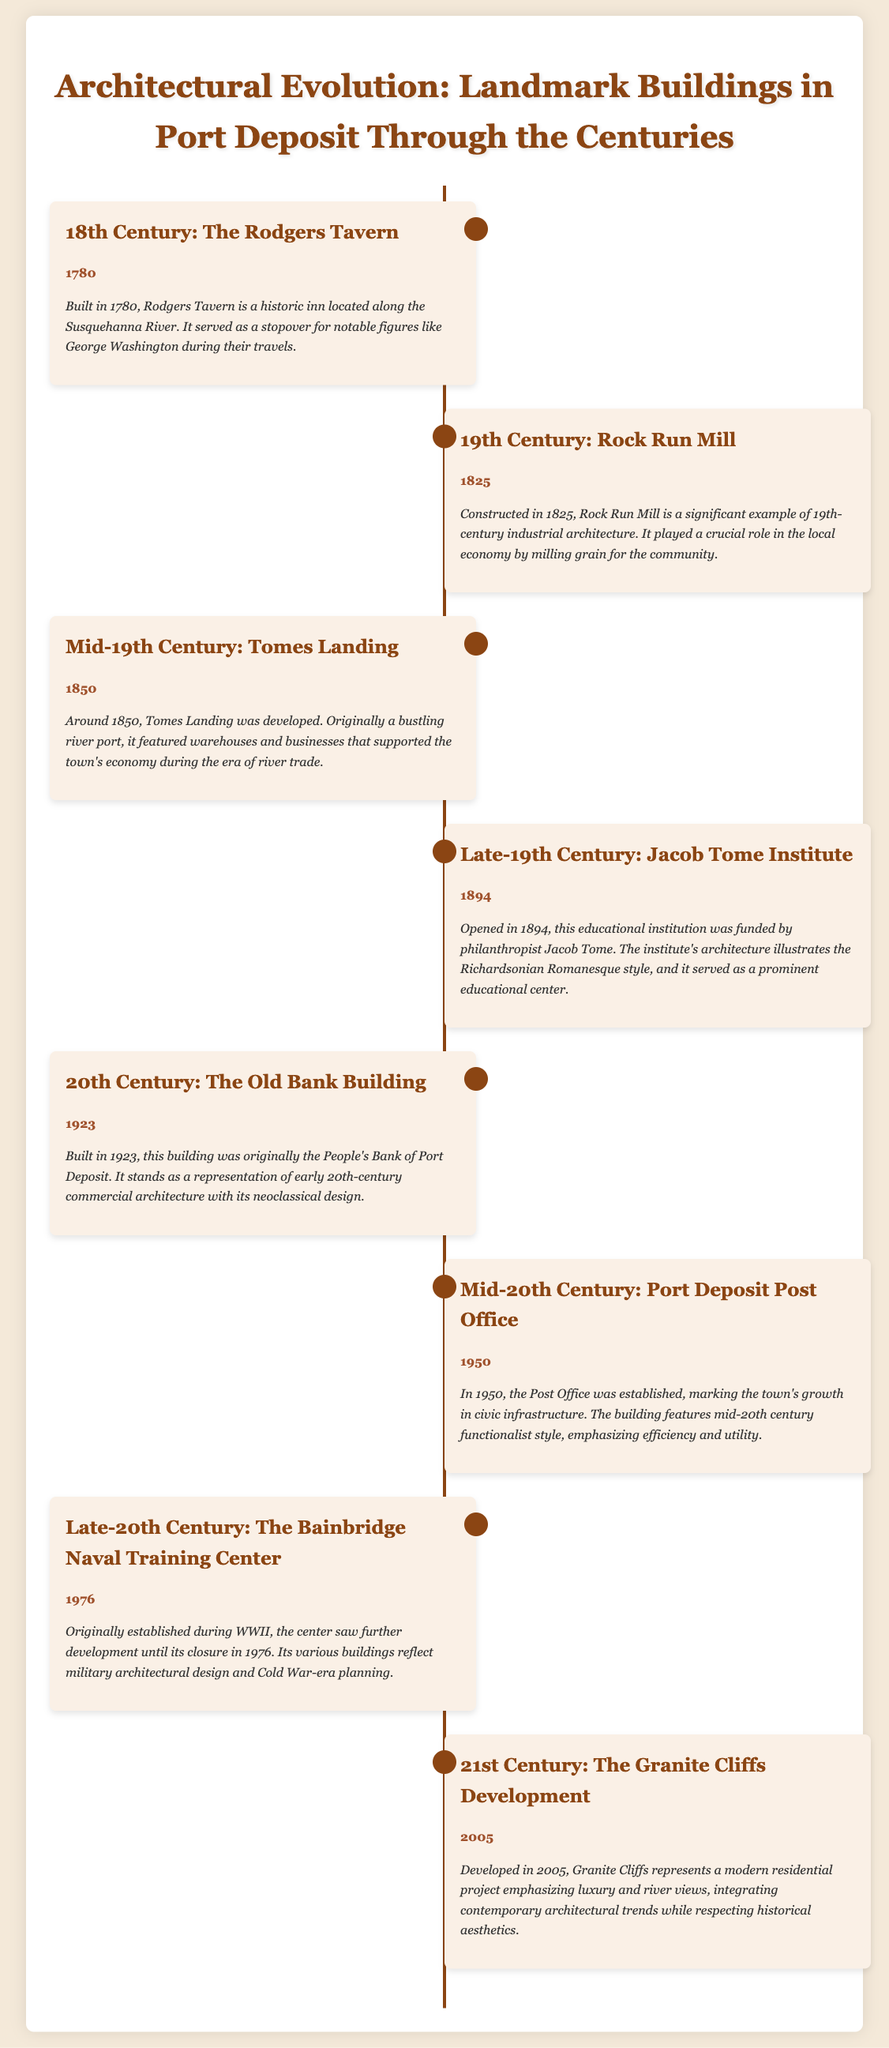What year was Rodgers Tavern built? The document states that Rodgers Tavern was built in the year 1780.
Answer: 1780 What architectural style is the Jacob Tome Institute associated with? The document describes the Jacob Tome Institute's architecture as illustrative of the Richardsonian Romanesque style.
Answer: Richardsonian Romanesque Which building was originally the People's Bank of Port Deposit? The Old Bank Building is mentioned as the original People's Bank of Port Deposit in the document.
Answer: The Old Bank Building When was the Port Deposit Post Office established? According to the document, the Port Deposit Post Office was established in the year 1950.
Answer: 1950 What significant role did Rock Run Mill play in the community? The document indicates that Rock Run Mill played a crucial role in milling grain for the community.
Answer: Milling grain What year represents the development of Granite Cliffs? The document states that the Granite Cliffs development took place in 2005.
Answer: 2005 What was the primary function of Tomes Landing in the 19th century? The document notes that Tomes Landing was originally a bustling river port supporting the town's economy during river trade.
Answer: River port What century does the Bainbridge Naval Training Center date back to? The document indicates that the Bainbridge Naval Training Center was originally established during World War II, thus referring to the 20th century.
Answer: 20th century 